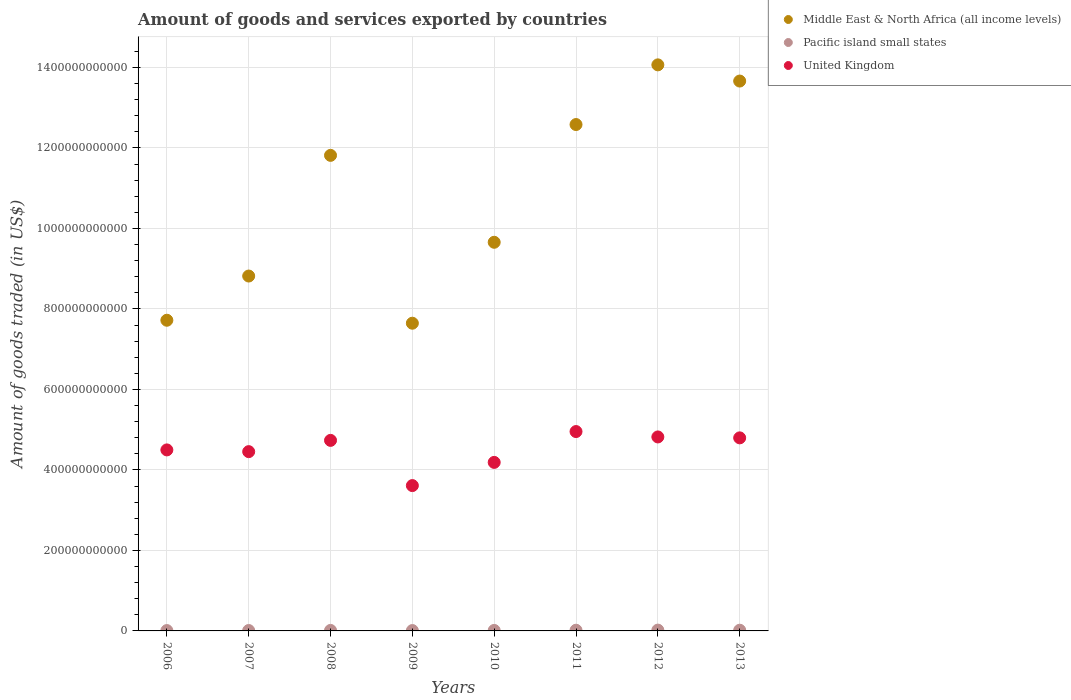How many different coloured dotlines are there?
Your answer should be very brief. 3. What is the total amount of goods and services exported in Middle East & North Africa (all income levels) in 2006?
Make the answer very short. 7.72e+11. Across all years, what is the maximum total amount of goods and services exported in Pacific island small states?
Keep it short and to the point. 2.01e+09. Across all years, what is the minimum total amount of goods and services exported in United Kingdom?
Your answer should be compact. 3.61e+11. What is the total total amount of goods and services exported in United Kingdom in the graph?
Your response must be concise. 3.61e+12. What is the difference between the total amount of goods and services exported in Middle East & North Africa (all income levels) in 2007 and that in 2012?
Your answer should be compact. -5.25e+11. What is the difference between the total amount of goods and services exported in United Kingdom in 2010 and the total amount of goods and services exported in Middle East & North Africa (all income levels) in 2008?
Your answer should be compact. -7.63e+11. What is the average total amount of goods and services exported in Middle East & North Africa (all income levels) per year?
Provide a short and direct response. 1.07e+12. In the year 2006, what is the difference between the total amount of goods and services exported in United Kingdom and total amount of goods and services exported in Middle East & North Africa (all income levels)?
Your response must be concise. -3.22e+11. In how many years, is the total amount of goods and services exported in United Kingdom greater than 760000000000 US$?
Give a very brief answer. 0. What is the ratio of the total amount of goods and services exported in Middle East & North Africa (all income levels) in 2006 to that in 2013?
Provide a succinct answer. 0.56. Is the total amount of goods and services exported in Pacific island small states in 2010 less than that in 2013?
Give a very brief answer. Yes. What is the difference between the highest and the second highest total amount of goods and services exported in Middle East & North Africa (all income levels)?
Provide a succinct answer. 4.02e+1. What is the difference between the highest and the lowest total amount of goods and services exported in Pacific island small states?
Your answer should be compact. 1.13e+09. Is the total amount of goods and services exported in Pacific island small states strictly greater than the total amount of goods and services exported in United Kingdom over the years?
Your answer should be compact. No. How many dotlines are there?
Make the answer very short. 3. What is the difference between two consecutive major ticks on the Y-axis?
Your answer should be very brief. 2.00e+11. Does the graph contain any zero values?
Ensure brevity in your answer.  No. How many legend labels are there?
Provide a short and direct response. 3. How are the legend labels stacked?
Provide a succinct answer. Vertical. What is the title of the graph?
Make the answer very short. Amount of goods and services exported by countries. Does "Bolivia" appear as one of the legend labels in the graph?
Your answer should be very brief. No. What is the label or title of the X-axis?
Your answer should be compact. Years. What is the label or title of the Y-axis?
Ensure brevity in your answer.  Amount of goods traded (in US$). What is the Amount of goods traded (in US$) in Middle East & North Africa (all income levels) in 2006?
Ensure brevity in your answer.  7.72e+11. What is the Amount of goods traded (in US$) of Pacific island small states in 2006?
Ensure brevity in your answer.  8.79e+08. What is the Amount of goods traded (in US$) of United Kingdom in 2006?
Give a very brief answer. 4.50e+11. What is the Amount of goods traded (in US$) in Middle East & North Africa (all income levels) in 2007?
Give a very brief answer. 8.82e+11. What is the Amount of goods traded (in US$) of Pacific island small states in 2007?
Offer a very short reply. 1.01e+09. What is the Amount of goods traded (in US$) in United Kingdom in 2007?
Provide a succinct answer. 4.45e+11. What is the Amount of goods traded (in US$) of Middle East & North Africa (all income levels) in 2008?
Offer a terse response. 1.18e+12. What is the Amount of goods traded (in US$) in Pacific island small states in 2008?
Offer a terse response. 1.25e+09. What is the Amount of goods traded (in US$) of United Kingdom in 2008?
Keep it short and to the point. 4.73e+11. What is the Amount of goods traded (in US$) of Middle East & North Africa (all income levels) in 2009?
Offer a terse response. 7.65e+11. What is the Amount of goods traded (in US$) in Pacific island small states in 2009?
Give a very brief answer. 9.17e+08. What is the Amount of goods traded (in US$) in United Kingdom in 2009?
Your answer should be very brief. 3.61e+11. What is the Amount of goods traded (in US$) of Middle East & North Africa (all income levels) in 2010?
Your response must be concise. 9.66e+11. What is the Amount of goods traded (in US$) in Pacific island small states in 2010?
Ensure brevity in your answer.  1.23e+09. What is the Amount of goods traded (in US$) of United Kingdom in 2010?
Ensure brevity in your answer.  4.19e+11. What is the Amount of goods traded (in US$) of Middle East & North Africa (all income levels) in 2011?
Your answer should be very brief. 1.26e+12. What is the Amount of goods traded (in US$) in Pacific island small states in 2011?
Provide a short and direct response. 1.72e+09. What is the Amount of goods traded (in US$) in United Kingdom in 2011?
Give a very brief answer. 4.95e+11. What is the Amount of goods traded (in US$) in Middle East & North Africa (all income levels) in 2012?
Provide a succinct answer. 1.41e+12. What is the Amount of goods traded (in US$) of Pacific island small states in 2012?
Your response must be concise. 2.01e+09. What is the Amount of goods traded (in US$) in United Kingdom in 2012?
Your answer should be very brief. 4.82e+11. What is the Amount of goods traded (in US$) in Middle East & North Africa (all income levels) in 2013?
Offer a very short reply. 1.37e+12. What is the Amount of goods traded (in US$) of Pacific island small states in 2013?
Offer a terse response. 1.75e+09. What is the Amount of goods traded (in US$) in United Kingdom in 2013?
Offer a very short reply. 4.80e+11. Across all years, what is the maximum Amount of goods traded (in US$) in Middle East & North Africa (all income levels)?
Give a very brief answer. 1.41e+12. Across all years, what is the maximum Amount of goods traded (in US$) of Pacific island small states?
Your response must be concise. 2.01e+09. Across all years, what is the maximum Amount of goods traded (in US$) of United Kingdom?
Your answer should be compact. 4.95e+11. Across all years, what is the minimum Amount of goods traded (in US$) in Middle East & North Africa (all income levels)?
Provide a short and direct response. 7.65e+11. Across all years, what is the minimum Amount of goods traded (in US$) in Pacific island small states?
Your answer should be compact. 8.79e+08. Across all years, what is the minimum Amount of goods traded (in US$) of United Kingdom?
Keep it short and to the point. 3.61e+11. What is the total Amount of goods traded (in US$) of Middle East & North Africa (all income levels) in the graph?
Your answer should be very brief. 8.60e+12. What is the total Amount of goods traded (in US$) in Pacific island small states in the graph?
Offer a very short reply. 1.08e+1. What is the total Amount of goods traded (in US$) of United Kingdom in the graph?
Provide a short and direct response. 3.61e+12. What is the difference between the Amount of goods traded (in US$) of Middle East & North Africa (all income levels) in 2006 and that in 2007?
Provide a short and direct response. -1.10e+11. What is the difference between the Amount of goods traded (in US$) of Pacific island small states in 2006 and that in 2007?
Offer a terse response. -1.31e+08. What is the difference between the Amount of goods traded (in US$) of United Kingdom in 2006 and that in 2007?
Provide a short and direct response. 4.31e+09. What is the difference between the Amount of goods traded (in US$) in Middle East & North Africa (all income levels) in 2006 and that in 2008?
Offer a terse response. -4.10e+11. What is the difference between the Amount of goods traded (in US$) of Pacific island small states in 2006 and that in 2008?
Keep it short and to the point. -3.69e+08. What is the difference between the Amount of goods traded (in US$) of United Kingdom in 2006 and that in 2008?
Keep it short and to the point. -2.37e+1. What is the difference between the Amount of goods traded (in US$) in Middle East & North Africa (all income levels) in 2006 and that in 2009?
Make the answer very short. 7.38e+09. What is the difference between the Amount of goods traded (in US$) of Pacific island small states in 2006 and that in 2009?
Keep it short and to the point. -3.78e+07. What is the difference between the Amount of goods traded (in US$) of United Kingdom in 2006 and that in 2009?
Provide a succinct answer. 8.87e+1. What is the difference between the Amount of goods traded (in US$) of Middle East & North Africa (all income levels) in 2006 and that in 2010?
Make the answer very short. -1.94e+11. What is the difference between the Amount of goods traded (in US$) of Pacific island small states in 2006 and that in 2010?
Give a very brief answer. -3.48e+08. What is the difference between the Amount of goods traded (in US$) of United Kingdom in 2006 and that in 2010?
Your answer should be compact. 3.10e+1. What is the difference between the Amount of goods traded (in US$) in Middle East & North Africa (all income levels) in 2006 and that in 2011?
Give a very brief answer. -4.86e+11. What is the difference between the Amount of goods traded (in US$) of Pacific island small states in 2006 and that in 2011?
Make the answer very short. -8.40e+08. What is the difference between the Amount of goods traded (in US$) of United Kingdom in 2006 and that in 2011?
Keep it short and to the point. -4.56e+1. What is the difference between the Amount of goods traded (in US$) of Middle East & North Africa (all income levels) in 2006 and that in 2012?
Make the answer very short. -6.35e+11. What is the difference between the Amount of goods traded (in US$) of Pacific island small states in 2006 and that in 2012?
Offer a terse response. -1.13e+09. What is the difference between the Amount of goods traded (in US$) of United Kingdom in 2006 and that in 2012?
Offer a very short reply. -3.22e+1. What is the difference between the Amount of goods traded (in US$) of Middle East & North Africa (all income levels) in 2006 and that in 2013?
Provide a short and direct response. -5.94e+11. What is the difference between the Amount of goods traded (in US$) in Pacific island small states in 2006 and that in 2013?
Make the answer very short. -8.70e+08. What is the difference between the Amount of goods traded (in US$) of United Kingdom in 2006 and that in 2013?
Your answer should be very brief. -2.99e+1. What is the difference between the Amount of goods traded (in US$) of Middle East & North Africa (all income levels) in 2007 and that in 2008?
Offer a terse response. -3.00e+11. What is the difference between the Amount of goods traded (in US$) of Pacific island small states in 2007 and that in 2008?
Your answer should be compact. -2.38e+08. What is the difference between the Amount of goods traded (in US$) in United Kingdom in 2007 and that in 2008?
Offer a very short reply. -2.80e+1. What is the difference between the Amount of goods traded (in US$) in Middle East & North Africa (all income levels) in 2007 and that in 2009?
Your answer should be very brief. 1.17e+11. What is the difference between the Amount of goods traded (in US$) in Pacific island small states in 2007 and that in 2009?
Give a very brief answer. 9.31e+07. What is the difference between the Amount of goods traded (in US$) of United Kingdom in 2007 and that in 2009?
Your answer should be very brief. 8.43e+1. What is the difference between the Amount of goods traded (in US$) in Middle East & North Africa (all income levels) in 2007 and that in 2010?
Provide a short and direct response. -8.39e+1. What is the difference between the Amount of goods traded (in US$) in Pacific island small states in 2007 and that in 2010?
Offer a very short reply. -2.17e+08. What is the difference between the Amount of goods traded (in US$) of United Kingdom in 2007 and that in 2010?
Provide a succinct answer. 2.67e+1. What is the difference between the Amount of goods traded (in US$) of Middle East & North Africa (all income levels) in 2007 and that in 2011?
Your answer should be compact. -3.76e+11. What is the difference between the Amount of goods traded (in US$) in Pacific island small states in 2007 and that in 2011?
Your response must be concise. -7.09e+08. What is the difference between the Amount of goods traded (in US$) of United Kingdom in 2007 and that in 2011?
Your answer should be compact. -4.99e+1. What is the difference between the Amount of goods traded (in US$) of Middle East & North Africa (all income levels) in 2007 and that in 2012?
Provide a short and direct response. -5.25e+11. What is the difference between the Amount of goods traded (in US$) of Pacific island small states in 2007 and that in 2012?
Offer a very short reply. -9.98e+08. What is the difference between the Amount of goods traded (in US$) of United Kingdom in 2007 and that in 2012?
Your answer should be compact. -3.65e+1. What is the difference between the Amount of goods traded (in US$) in Middle East & North Africa (all income levels) in 2007 and that in 2013?
Offer a very short reply. -4.85e+11. What is the difference between the Amount of goods traded (in US$) of Pacific island small states in 2007 and that in 2013?
Keep it short and to the point. -7.39e+08. What is the difference between the Amount of goods traded (in US$) in United Kingdom in 2007 and that in 2013?
Keep it short and to the point. -3.42e+1. What is the difference between the Amount of goods traded (in US$) in Middle East & North Africa (all income levels) in 2008 and that in 2009?
Your answer should be compact. 4.17e+11. What is the difference between the Amount of goods traded (in US$) of Pacific island small states in 2008 and that in 2009?
Your answer should be very brief. 3.31e+08. What is the difference between the Amount of goods traded (in US$) of United Kingdom in 2008 and that in 2009?
Provide a short and direct response. 1.12e+11. What is the difference between the Amount of goods traded (in US$) of Middle East & North Africa (all income levels) in 2008 and that in 2010?
Provide a short and direct response. 2.16e+11. What is the difference between the Amount of goods traded (in US$) of Pacific island small states in 2008 and that in 2010?
Ensure brevity in your answer.  2.08e+07. What is the difference between the Amount of goods traded (in US$) of United Kingdom in 2008 and that in 2010?
Offer a very short reply. 5.47e+1. What is the difference between the Amount of goods traded (in US$) of Middle East & North Africa (all income levels) in 2008 and that in 2011?
Keep it short and to the point. -7.66e+1. What is the difference between the Amount of goods traded (in US$) in Pacific island small states in 2008 and that in 2011?
Ensure brevity in your answer.  -4.71e+08. What is the difference between the Amount of goods traded (in US$) in United Kingdom in 2008 and that in 2011?
Offer a very short reply. -2.19e+1. What is the difference between the Amount of goods traded (in US$) in Middle East & North Africa (all income levels) in 2008 and that in 2012?
Provide a succinct answer. -2.25e+11. What is the difference between the Amount of goods traded (in US$) of Pacific island small states in 2008 and that in 2012?
Make the answer very short. -7.59e+08. What is the difference between the Amount of goods traded (in US$) in United Kingdom in 2008 and that in 2012?
Make the answer very short. -8.54e+09. What is the difference between the Amount of goods traded (in US$) of Middle East & North Africa (all income levels) in 2008 and that in 2013?
Keep it short and to the point. -1.85e+11. What is the difference between the Amount of goods traded (in US$) in Pacific island small states in 2008 and that in 2013?
Make the answer very short. -5.01e+08. What is the difference between the Amount of goods traded (in US$) of United Kingdom in 2008 and that in 2013?
Give a very brief answer. -6.25e+09. What is the difference between the Amount of goods traded (in US$) of Middle East & North Africa (all income levels) in 2009 and that in 2010?
Give a very brief answer. -2.01e+11. What is the difference between the Amount of goods traded (in US$) in Pacific island small states in 2009 and that in 2010?
Your answer should be very brief. -3.11e+08. What is the difference between the Amount of goods traded (in US$) of United Kingdom in 2009 and that in 2010?
Make the answer very short. -5.76e+1. What is the difference between the Amount of goods traded (in US$) of Middle East & North Africa (all income levels) in 2009 and that in 2011?
Your answer should be compact. -4.94e+11. What is the difference between the Amount of goods traded (in US$) in Pacific island small states in 2009 and that in 2011?
Provide a short and direct response. -8.02e+08. What is the difference between the Amount of goods traded (in US$) of United Kingdom in 2009 and that in 2011?
Offer a terse response. -1.34e+11. What is the difference between the Amount of goods traded (in US$) of Middle East & North Africa (all income levels) in 2009 and that in 2012?
Offer a terse response. -6.42e+11. What is the difference between the Amount of goods traded (in US$) in Pacific island small states in 2009 and that in 2012?
Offer a terse response. -1.09e+09. What is the difference between the Amount of goods traded (in US$) in United Kingdom in 2009 and that in 2012?
Your answer should be very brief. -1.21e+11. What is the difference between the Amount of goods traded (in US$) of Middle East & North Africa (all income levels) in 2009 and that in 2013?
Your answer should be compact. -6.02e+11. What is the difference between the Amount of goods traded (in US$) in Pacific island small states in 2009 and that in 2013?
Provide a succinct answer. -8.32e+08. What is the difference between the Amount of goods traded (in US$) in United Kingdom in 2009 and that in 2013?
Make the answer very short. -1.19e+11. What is the difference between the Amount of goods traded (in US$) in Middle East & North Africa (all income levels) in 2010 and that in 2011?
Make the answer very short. -2.93e+11. What is the difference between the Amount of goods traded (in US$) of Pacific island small states in 2010 and that in 2011?
Your answer should be compact. -4.92e+08. What is the difference between the Amount of goods traded (in US$) of United Kingdom in 2010 and that in 2011?
Offer a terse response. -7.66e+1. What is the difference between the Amount of goods traded (in US$) of Middle East & North Africa (all income levels) in 2010 and that in 2012?
Your response must be concise. -4.41e+11. What is the difference between the Amount of goods traded (in US$) in Pacific island small states in 2010 and that in 2012?
Your answer should be very brief. -7.80e+08. What is the difference between the Amount of goods traded (in US$) of United Kingdom in 2010 and that in 2012?
Your response must be concise. -6.32e+1. What is the difference between the Amount of goods traded (in US$) in Middle East & North Africa (all income levels) in 2010 and that in 2013?
Provide a succinct answer. -4.01e+11. What is the difference between the Amount of goods traded (in US$) in Pacific island small states in 2010 and that in 2013?
Make the answer very short. -5.22e+08. What is the difference between the Amount of goods traded (in US$) in United Kingdom in 2010 and that in 2013?
Give a very brief answer. -6.10e+1. What is the difference between the Amount of goods traded (in US$) of Middle East & North Africa (all income levels) in 2011 and that in 2012?
Ensure brevity in your answer.  -1.48e+11. What is the difference between the Amount of goods traded (in US$) in Pacific island small states in 2011 and that in 2012?
Offer a very short reply. -2.88e+08. What is the difference between the Amount of goods traded (in US$) of United Kingdom in 2011 and that in 2012?
Your answer should be very brief. 1.34e+1. What is the difference between the Amount of goods traded (in US$) in Middle East & North Africa (all income levels) in 2011 and that in 2013?
Give a very brief answer. -1.08e+11. What is the difference between the Amount of goods traded (in US$) of Pacific island small states in 2011 and that in 2013?
Ensure brevity in your answer.  -2.99e+07. What is the difference between the Amount of goods traded (in US$) in United Kingdom in 2011 and that in 2013?
Your answer should be very brief. 1.57e+1. What is the difference between the Amount of goods traded (in US$) of Middle East & North Africa (all income levels) in 2012 and that in 2013?
Provide a short and direct response. 4.02e+1. What is the difference between the Amount of goods traded (in US$) of Pacific island small states in 2012 and that in 2013?
Provide a succinct answer. 2.59e+08. What is the difference between the Amount of goods traded (in US$) of United Kingdom in 2012 and that in 2013?
Your response must be concise. 2.29e+09. What is the difference between the Amount of goods traded (in US$) of Middle East & North Africa (all income levels) in 2006 and the Amount of goods traded (in US$) of Pacific island small states in 2007?
Offer a very short reply. 7.71e+11. What is the difference between the Amount of goods traded (in US$) of Middle East & North Africa (all income levels) in 2006 and the Amount of goods traded (in US$) of United Kingdom in 2007?
Ensure brevity in your answer.  3.26e+11. What is the difference between the Amount of goods traded (in US$) of Pacific island small states in 2006 and the Amount of goods traded (in US$) of United Kingdom in 2007?
Ensure brevity in your answer.  -4.45e+11. What is the difference between the Amount of goods traded (in US$) of Middle East & North Africa (all income levels) in 2006 and the Amount of goods traded (in US$) of Pacific island small states in 2008?
Make the answer very short. 7.71e+11. What is the difference between the Amount of goods traded (in US$) of Middle East & North Africa (all income levels) in 2006 and the Amount of goods traded (in US$) of United Kingdom in 2008?
Your answer should be compact. 2.99e+11. What is the difference between the Amount of goods traded (in US$) of Pacific island small states in 2006 and the Amount of goods traded (in US$) of United Kingdom in 2008?
Keep it short and to the point. -4.73e+11. What is the difference between the Amount of goods traded (in US$) of Middle East & North Africa (all income levels) in 2006 and the Amount of goods traded (in US$) of Pacific island small states in 2009?
Give a very brief answer. 7.71e+11. What is the difference between the Amount of goods traded (in US$) of Middle East & North Africa (all income levels) in 2006 and the Amount of goods traded (in US$) of United Kingdom in 2009?
Provide a short and direct response. 4.11e+11. What is the difference between the Amount of goods traded (in US$) in Pacific island small states in 2006 and the Amount of goods traded (in US$) in United Kingdom in 2009?
Your answer should be very brief. -3.60e+11. What is the difference between the Amount of goods traded (in US$) in Middle East & North Africa (all income levels) in 2006 and the Amount of goods traded (in US$) in Pacific island small states in 2010?
Provide a short and direct response. 7.71e+11. What is the difference between the Amount of goods traded (in US$) of Middle East & North Africa (all income levels) in 2006 and the Amount of goods traded (in US$) of United Kingdom in 2010?
Your answer should be very brief. 3.53e+11. What is the difference between the Amount of goods traded (in US$) in Pacific island small states in 2006 and the Amount of goods traded (in US$) in United Kingdom in 2010?
Provide a succinct answer. -4.18e+11. What is the difference between the Amount of goods traded (in US$) of Middle East & North Africa (all income levels) in 2006 and the Amount of goods traded (in US$) of Pacific island small states in 2011?
Ensure brevity in your answer.  7.70e+11. What is the difference between the Amount of goods traded (in US$) in Middle East & North Africa (all income levels) in 2006 and the Amount of goods traded (in US$) in United Kingdom in 2011?
Offer a terse response. 2.77e+11. What is the difference between the Amount of goods traded (in US$) of Pacific island small states in 2006 and the Amount of goods traded (in US$) of United Kingdom in 2011?
Provide a succinct answer. -4.95e+11. What is the difference between the Amount of goods traded (in US$) of Middle East & North Africa (all income levels) in 2006 and the Amount of goods traded (in US$) of Pacific island small states in 2012?
Ensure brevity in your answer.  7.70e+11. What is the difference between the Amount of goods traded (in US$) of Middle East & North Africa (all income levels) in 2006 and the Amount of goods traded (in US$) of United Kingdom in 2012?
Make the answer very short. 2.90e+11. What is the difference between the Amount of goods traded (in US$) in Pacific island small states in 2006 and the Amount of goods traded (in US$) in United Kingdom in 2012?
Your answer should be very brief. -4.81e+11. What is the difference between the Amount of goods traded (in US$) in Middle East & North Africa (all income levels) in 2006 and the Amount of goods traded (in US$) in Pacific island small states in 2013?
Give a very brief answer. 7.70e+11. What is the difference between the Amount of goods traded (in US$) in Middle East & North Africa (all income levels) in 2006 and the Amount of goods traded (in US$) in United Kingdom in 2013?
Ensure brevity in your answer.  2.92e+11. What is the difference between the Amount of goods traded (in US$) of Pacific island small states in 2006 and the Amount of goods traded (in US$) of United Kingdom in 2013?
Make the answer very short. -4.79e+11. What is the difference between the Amount of goods traded (in US$) in Middle East & North Africa (all income levels) in 2007 and the Amount of goods traded (in US$) in Pacific island small states in 2008?
Your answer should be compact. 8.81e+11. What is the difference between the Amount of goods traded (in US$) in Middle East & North Africa (all income levels) in 2007 and the Amount of goods traded (in US$) in United Kingdom in 2008?
Offer a terse response. 4.08e+11. What is the difference between the Amount of goods traded (in US$) of Pacific island small states in 2007 and the Amount of goods traded (in US$) of United Kingdom in 2008?
Offer a terse response. -4.72e+11. What is the difference between the Amount of goods traded (in US$) of Middle East & North Africa (all income levels) in 2007 and the Amount of goods traded (in US$) of Pacific island small states in 2009?
Provide a succinct answer. 8.81e+11. What is the difference between the Amount of goods traded (in US$) of Middle East & North Africa (all income levels) in 2007 and the Amount of goods traded (in US$) of United Kingdom in 2009?
Give a very brief answer. 5.21e+11. What is the difference between the Amount of goods traded (in US$) in Pacific island small states in 2007 and the Amount of goods traded (in US$) in United Kingdom in 2009?
Provide a succinct answer. -3.60e+11. What is the difference between the Amount of goods traded (in US$) in Middle East & North Africa (all income levels) in 2007 and the Amount of goods traded (in US$) in Pacific island small states in 2010?
Your response must be concise. 8.81e+11. What is the difference between the Amount of goods traded (in US$) in Middle East & North Africa (all income levels) in 2007 and the Amount of goods traded (in US$) in United Kingdom in 2010?
Give a very brief answer. 4.63e+11. What is the difference between the Amount of goods traded (in US$) of Pacific island small states in 2007 and the Amount of goods traded (in US$) of United Kingdom in 2010?
Your answer should be very brief. -4.18e+11. What is the difference between the Amount of goods traded (in US$) in Middle East & North Africa (all income levels) in 2007 and the Amount of goods traded (in US$) in Pacific island small states in 2011?
Your response must be concise. 8.80e+11. What is the difference between the Amount of goods traded (in US$) of Middle East & North Africa (all income levels) in 2007 and the Amount of goods traded (in US$) of United Kingdom in 2011?
Ensure brevity in your answer.  3.86e+11. What is the difference between the Amount of goods traded (in US$) in Pacific island small states in 2007 and the Amount of goods traded (in US$) in United Kingdom in 2011?
Offer a terse response. -4.94e+11. What is the difference between the Amount of goods traded (in US$) of Middle East & North Africa (all income levels) in 2007 and the Amount of goods traded (in US$) of Pacific island small states in 2012?
Keep it short and to the point. 8.80e+11. What is the difference between the Amount of goods traded (in US$) of Middle East & North Africa (all income levels) in 2007 and the Amount of goods traded (in US$) of United Kingdom in 2012?
Provide a short and direct response. 4.00e+11. What is the difference between the Amount of goods traded (in US$) in Pacific island small states in 2007 and the Amount of goods traded (in US$) in United Kingdom in 2012?
Ensure brevity in your answer.  -4.81e+11. What is the difference between the Amount of goods traded (in US$) in Middle East & North Africa (all income levels) in 2007 and the Amount of goods traded (in US$) in Pacific island small states in 2013?
Offer a terse response. 8.80e+11. What is the difference between the Amount of goods traded (in US$) of Middle East & North Africa (all income levels) in 2007 and the Amount of goods traded (in US$) of United Kingdom in 2013?
Your answer should be compact. 4.02e+11. What is the difference between the Amount of goods traded (in US$) of Pacific island small states in 2007 and the Amount of goods traded (in US$) of United Kingdom in 2013?
Make the answer very short. -4.79e+11. What is the difference between the Amount of goods traded (in US$) of Middle East & North Africa (all income levels) in 2008 and the Amount of goods traded (in US$) of Pacific island small states in 2009?
Your response must be concise. 1.18e+12. What is the difference between the Amount of goods traded (in US$) in Middle East & North Africa (all income levels) in 2008 and the Amount of goods traded (in US$) in United Kingdom in 2009?
Keep it short and to the point. 8.21e+11. What is the difference between the Amount of goods traded (in US$) in Pacific island small states in 2008 and the Amount of goods traded (in US$) in United Kingdom in 2009?
Ensure brevity in your answer.  -3.60e+11. What is the difference between the Amount of goods traded (in US$) in Middle East & North Africa (all income levels) in 2008 and the Amount of goods traded (in US$) in Pacific island small states in 2010?
Ensure brevity in your answer.  1.18e+12. What is the difference between the Amount of goods traded (in US$) of Middle East & North Africa (all income levels) in 2008 and the Amount of goods traded (in US$) of United Kingdom in 2010?
Give a very brief answer. 7.63e+11. What is the difference between the Amount of goods traded (in US$) in Pacific island small states in 2008 and the Amount of goods traded (in US$) in United Kingdom in 2010?
Make the answer very short. -4.18e+11. What is the difference between the Amount of goods traded (in US$) in Middle East & North Africa (all income levels) in 2008 and the Amount of goods traded (in US$) in Pacific island small states in 2011?
Ensure brevity in your answer.  1.18e+12. What is the difference between the Amount of goods traded (in US$) in Middle East & North Africa (all income levels) in 2008 and the Amount of goods traded (in US$) in United Kingdom in 2011?
Your response must be concise. 6.86e+11. What is the difference between the Amount of goods traded (in US$) in Pacific island small states in 2008 and the Amount of goods traded (in US$) in United Kingdom in 2011?
Your answer should be very brief. -4.94e+11. What is the difference between the Amount of goods traded (in US$) in Middle East & North Africa (all income levels) in 2008 and the Amount of goods traded (in US$) in Pacific island small states in 2012?
Your answer should be very brief. 1.18e+12. What is the difference between the Amount of goods traded (in US$) of Middle East & North Africa (all income levels) in 2008 and the Amount of goods traded (in US$) of United Kingdom in 2012?
Offer a terse response. 7.00e+11. What is the difference between the Amount of goods traded (in US$) in Pacific island small states in 2008 and the Amount of goods traded (in US$) in United Kingdom in 2012?
Your answer should be compact. -4.81e+11. What is the difference between the Amount of goods traded (in US$) in Middle East & North Africa (all income levels) in 2008 and the Amount of goods traded (in US$) in Pacific island small states in 2013?
Provide a succinct answer. 1.18e+12. What is the difference between the Amount of goods traded (in US$) in Middle East & North Africa (all income levels) in 2008 and the Amount of goods traded (in US$) in United Kingdom in 2013?
Provide a succinct answer. 7.02e+11. What is the difference between the Amount of goods traded (in US$) in Pacific island small states in 2008 and the Amount of goods traded (in US$) in United Kingdom in 2013?
Make the answer very short. -4.78e+11. What is the difference between the Amount of goods traded (in US$) in Middle East & North Africa (all income levels) in 2009 and the Amount of goods traded (in US$) in Pacific island small states in 2010?
Offer a very short reply. 7.63e+11. What is the difference between the Amount of goods traded (in US$) of Middle East & North Africa (all income levels) in 2009 and the Amount of goods traded (in US$) of United Kingdom in 2010?
Offer a very short reply. 3.46e+11. What is the difference between the Amount of goods traded (in US$) of Pacific island small states in 2009 and the Amount of goods traded (in US$) of United Kingdom in 2010?
Keep it short and to the point. -4.18e+11. What is the difference between the Amount of goods traded (in US$) in Middle East & North Africa (all income levels) in 2009 and the Amount of goods traded (in US$) in Pacific island small states in 2011?
Provide a short and direct response. 7.63e+11. What is the difference between the Amount of goods traded (in US$) of Middle East & North Africa (all income levels) in 2009 and the Amount of goods traded (in US$) of United Kingdom in 2011?
Offer a terse response. 2.69e+11. What is the difference between the Amount of goods traded (in US$) of Pacific island small states in 2009 and the Amount of goods traded (in US$) of United Kingdom in 2011?
Provide a short and direct response. -4.94e+11. What is the difference between the Amount of goods traded (in US$) in Middle East & North Africa (all income levels) in 2009 and the Amount of goods traded (in US$) in Pacific island small states in 2012?
Keep it short and to the point. 7.63e+11. What is the difference between the Amount of goods traded (in US$) in Middle East & North Africa (all income levels) in 2009 and the Amount of goods traded (in US$) in United Kingdom in 2012?
Give a very brief answer. 2.83e+11. What is the difference between the Amount of goods traded (in US$) in Pacific island small states in 2009 and the Amount of goods traded (in US$) in United Kingdom in 2012?
Your answer should be compact. -4.81e+11. What is the difference between the Amount of goods traded (in US$) of Middle East & North Africa (all income levels) in 2009 and the Amount of goods traded (in US$) of Pacific island small states in 2013?
Keep it short and to the point. 7.63e+11. What is the difference between the Amount of goods traded (in US$) in Middle East & North Africa (all income levels) in 2009 and the Amount of goods traded (in US$) in United Kingdom in 2013?
Your answer should be compact. 2.85e+11. What is the difference between the Amount of goods traded (in US$) in Pacific island small states in 2009 and the Amount of goods traded (in US$) in United Kingdom in 2013?
Your answer should be very brief. -4.79e+11. What is the difference between the Amount of goods traded (in US$) in Middle East & North Africa (all income levels) in 2010 and the Amount of goods traded (in US$) in Pacific island small states in 2011?
Your answer should be very brief. 9.64e+11. What is the difference between the Amount of goods traded (in US$) of Middle East & North Africa (all income levels) in 2010 and the Amount of goods traded (in US$) of United Kingdom in 2011?
Your answer should be very brief. 4.70e+11. What is the difference between the Amount of goods traded (in US$) in Pacific island small states in 2010 and the Amount of goods traded (in US$) in United Kingdom in 2011?
Make the answer very short. -4.94e+11. What is the difference between the Amount of goods traded (in US$) of Middle East & North Africa (all income levels) in 2010 and the Amount of goods traded (in US$) of Pacific island small states in 2012?
Provide a short and direct response. 9.64e+11. What is the difference between the Amount of goods traded (in US$) of Middle East & North Africa (all income levels) in 2010 and the Amount of goods traded (in US$) of United Kingdom in 2012?
Offer a very short reply. 4.84e+11. What is the difference between the Amount of goods traded (in US$) in Pacific island small states in 2010 and the Amount of goods traded (in US$) in United Kingdom in 2012?
Ensure brevity in your answer.  -4.81e+11. What is the difference between the Amount of goods traded (in US$) in Middle East & North Africa (all income levels) in 2010 and the Amount of goods traded (in US$) in Pacific island small states in 2013?
Make the answer very short. 9.64e+11. What is the difference between the Amount of goods traded (in US$) of Middle East & North Africa (all income levels) in 2010 and the Amount of goods traded (in US$) of United Kingdom in 2013?
Provide a succinct answer. 4.86e+11. What is the difference between the Amount of goods traded (in US$) of Pacific island small states in 2010 and the Amount of goods traded (in US$) of United Kingdom in 2013?
Your response must be concise. -4.78e+11. What is the difference between the Amount of goods traded (in US$) of Middle East & North Africa (all income levels) in 2011 and the Amount of goods traded (in US$) of Pacific island small states in 2012?
Your response must be concise. 1.26e+12. What is the difference between the Amount of goods traded (in US$) in Middle East & North Africa (all income levels) in 2011 and the Amount of goods traded (in US$) in United Kingdom in 2012?
Your response must be concise. 7.76e+11. What is the difference between the Amount of goods traded (in US$) of Pacific island small states in 2011 and the Amount of goods traded (in US$) of United Kingdom in 2012?
Your response must be concise. -4.80e+11. What is the difference between the Amount of goods traded (in US$) in Middle East & North Africa (all income levels) in 2011 and the Amount of goods traded (in US$) in Pacific island small states in 2013?
Make the answer very short. 1.26e+12. What is the difference between the Amount of goods traded (in US$) in Middle East & North Africa (all income levels) in 2011 and the Amount of goods traded (in US$) in United Kingdom in 2013?
Your answer should be very brief. 7.79e+11. What is the difference between the Amount of goods traded (in US$) of Pacific island small states in 2011 and the Amount of goods traded (in US$) of United Kingdom in 2013?
Your answer should be compact. -4.78e+11. What is the difference between the Amount of goods traded (in US$) of Middle East & North Africa (all income levels) in 2012 and the Amount of goods traded (in US$) of Pacific island small states in 2013?
Keep it short and to the point. 1.40e+12. What is the difference between the Amount of goods traded (in US$) in Middle East & North Africa (all income levels) in 2012 and the Amount of goods traded (in US$) in United Kingdom in 2013?
Ensure brevity in your answer.  9.27e+11. What is the difference between the Amount of goods traded (in US$) of Pacific island small states in 2012 and the Amount of goods traded (in US$) of United Kingdom in 2013?
Keep it short and to the point. -4.78e+11. What is the average Amount of goods traded (in US$) in Middle East & North Africa (all income levels) per year?
Your answer should be compact. 1.07e+12. What is the average Amount of goods traded (in US$) in Pacific island small states per year?
Ensure brevity in your answer.  1.34e+09. What is the average Amount of goods traded (in US$) in United Kingdom per year?
Keep it short and to the point. 4.51e+11. In the year 2006, what is the difference between the Amount of goods traded (in US$) in Middle East & North Africa (all income levels) and Amount of goods traded (in US$) in Pacific island small states?
Offer a very short reply. 7.71e+11. In the year 2006, what is the difference between the Amount of goods traded (in US$) in Middle East & North Africa (all income levels) and Amount of goods traded (in US$) in United Kingdom?
Provide a succinct answer. 3.22e+11. In the year 2006, what is the difference between the Amount of goods traded (in US$) in Pacific island small states and Amount of goods traded (in US$) in United Kingdom?
Your answer should be compact. -4.49e+11. In the year 2007, what is the difference between the Amount of goods traded (in US$) in Middle East & North Africa (all income levels) and Amount of goods traded (in US$) in Pacific island small states?
Make the answer very short. 8.81e+11. In the year 2007, what is the difference between the Amount of goods traded (in US$) of Middle East & North Africa (all income levels) and Amount of goods traded (in US$) of United Kingdom?
Provide a succinct answer. 4.36e+11. In the year 2007, what is the difference between the Amount of goods traded (in US$) of Pacific island small states and Amount of goods traded (in US$) of United Kingdom?
Give a very brief answer. -4.44e+11. In the year 2008, what is the difference between the Amount of goods traded (in US$) in Middle East & North Africa (all income levels) and Amount of goods traded (in US$) in Pacific island small states?
Keep it short and to the point. 1.18e+12. In the year 2008, what is the difference between the Amount of goods traded (in US$) in Middle East & North Africa (all income levels) and Amount of goods traded (in US$) in United Kingdom?
Provide a succinct answer. 7.08e+11. In the year 2008, what is the difference between the Amount of goods traded (in US$) of Pacific island small states and Amount of goods traded (in US$) of United Kingdom?
Ensure brevity in your answer.  -4.72e+11. In the year 2009, what is the difference between the Amount of goods traded (in US$) in Middle East & North Africa (all income levels) and Amount of goods traded (in US$) in Pacific island small states?
Your answer should be compact. 7.64e+11. In the year 2009, what is the difference between the Amount of goods traded (in US$) of Middle East & North Africa (all income levels) and Amount of goods traded (in US$) of United Kingdom?
Provide a short and direct response. 4.03e+11. In the year 2009, what is the difference between the Amount of goods traded (in US$) in Pacific island small states and Amount of goods traded (in US$) in United Kingdom?
Your answer should be very brief. -3.60e+11. In the year 2010, what is the difference between the Amount of goods traded (in US$) of Middle East & North Africa (all income levels) and Amount of goods traded (in US$) of Pacific island small states?
Make the answer very short. 9.64e+11. In the year 2010, what is the difference between the Amount of goods traded (in US$) of Middle East & North Africa (all income levels) and Amount of goods traded (in US$) of United Kingdom?
Your answer should be very brief. 5.47e+11. In the year 2010, what is the difference between the Amount of goods traded (in US$) in Pacific island small states and Amount of goods traded (in US$) in United Kingdom?
Your answer should be compact. -4.18e+11. In the year 2011, what is the difference between the Amount of goods traded (in US$) in Middle East & North Africa (all income levels) and Amount of goods traded (in US$) in Pacific island small states?
Offer a very short reply. 1.26e+12. In the year 2011, what is the difference between the Amount of goods traded (in US$) in Middle East & North Africa (all income levels) and Amount of goods traded (in US$) in United Kingdom?
Offer a terse response. 7.63e+11. In the year 2011, what is the difference between the Amount of goods traded (in US$) of Pacific island small states and Amount of goods traded (in US$) of United Kingdom?
Make the answer very short. -4.94e+11. In the year 2012, what is the difference between the Amount of goods traded (in US$) in Middle East & North Africa (all income levels) and Amount of goods traded (in US$) in Pacific island small states?
Offer a very short reply. 1.40e+12. In the year 2012, what is the difference between the Amount of goods traded (in US$) of Middle East & North Africa (all income levels) and Amount of goods traded (in US$) of United Kingdom?
Give a very brief answer. 9.25e+11. In the year 2012, what is the difference between the Amount of goods traded (in US$) in Pacific island small states and Amount of goods traded (in US$) in United Kingdom?
Your answer should be compact. -4.80e+11. In the year 2013, what is the difference between the Amount of goods traded (in US$) in Middle East & North Africa (all income levels) and Amount of goods traded (in US$) in Pacific island small states?
Your answer should be compact. 1.36e+12. In the year 2013, what is the difference between the Amount of goods traded (in US$) of Middle East & North Africa (all income levels) and Amount of goods traded (in US$) of United Kingdom?
Make the answer very short. 8.87e+11. In the year 2013, what is the difference between the Amount of goods traded (in US$) in Pacific island small states and Amount of goods traded (in US$) in United Kingdom?
Your response must be concise. -4.78e+11. What is the ratio of the Amount of goods traded (in US$) in Middle East & North Africa (all income levels) in 2006 to that in 2007?
Ensure brevity in your answer.  0.88. What is the ratio of the Amount of goods traded (in US$) of Pacific island small states in 2006 to that in 2007?
Ensure brevity in your answer.  0.87. What is the ratio of the Amount of goods traded (in US$) in United Kingdom in 2006 to that in 2007?
Provide a short and direct response. 1.01. What is the ratio of the Amount of goods traded (in US$) of Middle East & North Africa (all income levels) in 2006 to that in 2008?
Offer a very short reply. 0.65. What is the ratio of the Amount of goods traded (in US$) in Pacific island small states in 2006 to that in 2008?
Make the answer very short. 0.7. What is the ratio of the Amount of goods traded (in US$) in Middle East & North Africa (all income levels) in 2006 to that in 2009?
Keep it short and to the point. 1.01. What is the ratio of the Amount of goods traded (in US$) of Pacific island small states in 2006 to that in 2009?
Make the answer very short. 0.96. What is the ratio of the Amount of goods traded (in US$) of United Kingdom in 2006 to that in 2009?
Give a very brief answer. 1.25. What is the ratio of the Amount of goods traded (in US$) in Middle East & North Africa (all income levels) in 2006 to that in 2010?
Provide a short and direct response. 0.8. What is the ratio of the Amount of goods traded (in US$) in Pacific island small states in 2006 to that in 2010?
Ensure brevity in your answer.  0.72. What is the ratio of the Amount of goods traded (in US$) in United Kingdom in 2006 to that in 2010?
Offer a terse response. 1.07. What is the ratio of the Amount of goods traded (in US$) in Middle East & North Africa (all income levels) in 2006 to that in 2011?
Your answer should be very brief. 0.61. What is the ratio of the Amount of goods traded (in US$) of Pacific island small states in 2006 to that in 2011?
Give a very brief answer. 0.51. What is the ratio of the Amount of goods traded (in US$) in United Kingdom in 2006 to that in 2011?
Give a very brief answer. 0.91. What is the ratio of the Amount of goods traded (in US$) in Middle East & North Africa (all income levels) in 2006 to that in 2012?
Your response must be concise. 0.55. What is the ratio of the Amount of goods traded (in US$) of Pacific island small states in 2006 to that in 2012?
Ensure brevity in your answer.  0.44. What is the ratio of the Amount of goods traded (in US$) in United Kingdom in 2006 to that in 2012?
Your response must be concise. 0.93. What is the ratio of the Amount of goods traded (in US$) of Middle East & North Africa (all income levels) in 2006 to that in 2013?
Offer a terse response. 0.56. What is the ratio of the Amount of goods traded (in US$) of Pacific island small states in 2006 to that in 2013?
Your answer should be very brief. 0.5. What is the ratio of the Amount of goods traded (in US$) of United Kingdom in 2006 to that in 2013?
Offer a terse response. 0.94. What is the ratio of the Amount of goods traded (in US$) of Middle East & North Africa (all income levels) in 2007 to that in 2008?
Your answer should be compact. 0.75. What is the ratio of the Amount of goods traded (in US$) of Pacific island small states in 2007 to that in 2008?
Ensure brevity in your answer.  0.81. What is the ratio of the Amount of goods traded (in US$) in United Kingdom in 2007 to that in 2008?
Make the answer very short. 0.94. What is the ratio of the Amount of goods traded (in US$) of Middle East & North Africa (all income levels) in 2007 to that in 2009?
Make the answer very short. 1.15. What is the ratio of the Amount of goods traded (in US$) of Pacific island small states in 2007 to that in 2009?
Your answer should be compact. 1.1. What is the ratio of the Amount of goods traded (in US$) in United Kingdom in 2007 to that in 2009?
Give a very brief answer. 1.23. What is the ratio of the Amount of goods traded (in US$) of Middle East & North Africa (all income levels) in 2007 to that in 2010?
Keep it short and to the point. 0.91. What is the ratio of the Amount of goods traded (in US$) in Pacific island small states in 2007 to that in 2010?
Your answer should be compact. 0.82. What is the ratio of the Amount of goods traded (in US$) in United Kingdom in 2007 to that in 2010?
Provide a succinct answer. 1.06. What is the ratio of the Amount of goods traded (in US$) of Middle East & North Africa (all income levels) in 2007 to that in 2011?
Your response must be concise. 0.7. What is the ratio of the Amount of goods traded (in US$) in Pacific island small states in 2007 to that in 2011?
Give a very brief answer. 0.59. What is the ratio of the Amount of goods traded (in US$) of United Kingdom in 2007 to that in 2011?
Give a very brief answer. 0.9. What is the ratio of the Amount of goods traded (in US$) in Middle East & North Africa (all income levels) in 2007 to that in 2012?
Your response must be concise. 0.63. What is the ratio of the Amount of goods traded (in US$) in Pacific island small states in 2007 to that in 2012?
Keep it short and to the point. 0.5. What is the ratio of the Amount of goods traded (in US$) of United Kingdom in 2007 to that in 2012?
Provide a succinct answer. 0.92. What is the ratio of the Amount of goods traded (in US$) in Middle East & North Africa (all income levels) in 2007 to that in 2013?
Provide a short and direct response. 0.65. What is the ratio of the Amount of goods traded (in US$) in Pacific island small states in 2007 to that in 2013?
Offer a very short reply. 0.58. What is the ratio of the Amount of goods traded (in US$) in United Kingdom in 2007 to that in 2013?
Provide a short and direct response. 0.93. What is the ratio of the Amount of goods traded (in US$) of Middle East & North Africa (all income levels) in 2008 to that in 2009?
Your answer should be compact. 1.55. What is the ratio of the Amount of goods traded (in US$) in Pacific island small states in 2008 to that in 2009?
Offer a terse response. 1.36. What is the ratio of the Amount of goods traded (in US$) in United Kingdom in 2008 to that in 2009?
Keep it short and to the point. 1.31. What is the ratio of the Amount of goods traded (in US$) of Middle East & North Africa (all income levels) in 2008 to that in 2010?
Your response must be concise. 1.22. What is the ratio of the Amount of goods traded (in US$) in Pacific island small states in 2008 to that in 2010?
Your response must be concise. 1.02. What is the ratio of the Amount of goods traded (in US$) in United Kingdom in 2008 to that in 2010?
Provide a succinct answer. 1.13. What is the ratio of the Amount of goods traded (in US$) of Middle East & North Africa (all income levels) in 2008 to that in 2011?
Your answer should be very brief. 0.94. What is the ratio of the Amount of goods traded (in US$) of Pacific island small states in 2008 to that in 2011?
Make the answer very short. 0.73. What is the ratio of the Amount of goods traded (in US$) of United Kingdom in 2008 to that in 2011?
Keep it short and to the point. 0.96. What is the ratio of the Amount of goods traded (in US$) in Middle East & North Africa (all income levels) in 2008 to that in 2012?
Keep it short and to the point. 0.84. What is the ratio of the Amount of goods traded (in US$) of Pacific island small states in 2008 to that in 2012?
Offer a very short reply. 0.62. What is the ratio of the Amount of goods traded (in US$) of United Kingdom in 2008 to that in 2012?
Provide a succinct answer. 0.98. What is the ratio of the Amount of goods traded (in US$) of Middle East & North Africa (all income levels) in 2008 to that in 2013?
Ensure brevity in your answer.  0.86. What is the ratio of the Amount of goods traded (in US$) of Pacific island small states in 2008 to that in 2013?
Offer a terse response. 0.71. What is the ratio of the Amount of goods traded (in US$) in United Kingdom in 2008 to that in 2013?
Give a very brief answer. 0.99. What is the ratio of the Amount of goods traded (in US$) of Middle East & North Africa (all income levels) in 2009 to that in 2010?
Your answer should be compact. 0.79. What is the ratio of the Amount of goods traded (in US$) in Pacific island small states in 2009 to that in 2010?
Offer a terse response. 0.75. What is the ratio of the Amount of goods traded (in US$) of United Kingdom in 2009 to that in 2010?
Your answer should be compact. 0.86. What is the ratio of the Amount of goods traded (in US$) in Middle East & North Africa (all income levels) in 2009 to that in 2011?
Offer a terse response. 0.61. What is the ratio of the Amount of goods traded (in US$) in Pacific island small states in 2009 to that in 2011?
Provide a short and direct response. 0.53. What is the ratio of the Amount of goods traded (in US$) in United Kingdom in 2009 to that in 2011?
Give a very brief answer. 0.73. What is the ratio of the Amount of goods traded (in US$) of Middle East & North Africa (all income levels) in 2009 to that in 2012?
Your answer should be compact. 0.54. What is the ratio of the Amount of goods traded (in US$) in Pacific island small states in 2009 to that in 2012?
Your answer should be very brief. 0.46. What is the ratio of the Amount of goods traded (in US$) of United Kingdom in 2009 to that in 2012?
Offer a very short reply. 0.75. What is the ratio of the Amount of goods traded (in US$) in Middle East & North Africa (all income levels) in 2009 to that in 2013?
Make the answer very short. 0.56. What is the ratio of the Amount of goods traded (in US$) of Pacific island small states in 2009 to that in 2013?
Ensure brevity in your answer.  0.52. What is the ratio of the Amount of goods traded (in US$) of United Kingdom in 2009 to that in 2013?
Offer a very short reply. 0.75. What is the ratio of the Amount of goods traded (in US$) in Middle East & North Africa (all income levels) in 2010 to that in 2011?
Your answer should be compact. 0.77. What is the ratio of the Amount of goods traded (in US$) of Pacific island small states in 2010 to that in 2011?
Keep it short and to the point. 0.71. What is the ratio of the Amount of goods traded (in US$) in United Kingdom in 2010 to that in 2011?
Give a very brief answer. 0.85. What is the ratio of the Amount of goods traded (in US$) in Middle East & North Africa (all income levels) in 2010 to that in 2012?
Keep it short and to the point. 0.69. What is the ratio of the Amount of goods traded (in US$) in Pacific island small states in 2010 to that in 2012?
Keep it short and to the point. 0.61. What is the ratio of the Amount of goods traded (in US$) of United Kingdom in 2010 to that in 2012?
Offer a very short reply. 0.87. What is the ratio of the Amount of goods traded (in US$) of Middle East & North Africa (all income levels) in 2010 to that in 2013?
Keep it short and to the point. 0.71. What is the ratio of the Amount of goods traded (in US$) in Pacific island small states in 2010 to that in 2013?
Provide a short and direct response. 0.7. What is the ratio of the Amount of goods traded (in US$) of United Kingdom in 2010 to that in 2013?
Your answer should be compact. 0.87. What is the ratio of the Amount of goods traded (in US$) of Middle East & North Africa (all income levels) in 2011 to that in 2012?
Your response must be concise. 0.89. What is the ratio of the Amount of goods traded (in US$) in Pacific island small states in 2011 to that in 2012?
Your answer should be very brief. 0.86. What is the ratio of the Amount of goods traded (in US$) in United Kingdom in 2011 to that in 2012?
Make the answer very short. 1.03. What is the ratio of the Amount of goods traded (in US$) in Middle East & North Africa (all income levels) in 2011 to that in 2013?
Offer a very short reply. 0.92. What is the ratio of the Amount of goods traded (in US$) of Pacific island small states in 2011 to that in 2013?
Provide a succinct answer. 0.98. What is the ratio of the Amount of goods traded (in US$) in United Kingdom in 2011 to that in 2013?
Ensure brevity in your answer.  1.03. What is the ratio of the Amount of goods traded (in US$) of Middle East & North Africa (all income levels) in 2012 to that in 2013?
Offer a very short reply. 1.03. What is the ratio of the Amount of goods traded (in US$) of Pacific island small states in 2012 to that in 2013?
Ensure brevity in your answer.  1.15. What is the ratio of the Amount of goods traded (in US$) of United Kingdom in 2012 to that in 2013?
Offer a very short reply. 1. What is the difference between the highest and the second highest Amount of goods traded (in US$) in Middle East & North Africa (all income levels)?
Your answer should be compact. 4.02e+1. What is the difference between the highest and the second highest Amount of goods traded (in US$) of Pacific island small states?
Make the answer very short. 2.59e+08. What is the difference between the highest and the second highest Amount of goods traded (in US$) of United Kingdom?
Offer a very short reply. 1.34e+1. What is the difference between the highest and the lowest Amount of goods traded (in US$) of Middle East & North Africa (all income levels)?
Offer a very short reply. 6.42e+11. What is the difference between the highest and the lowest Amount of goods traded (in US$) in Pacific island small states?
Your response must be concise. 1.13e+09. What is the difference between the highest and the lowest Amount of goods traded (in US$) of United Kingdom?
Your answer should be compact. 1.34e+11. 